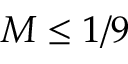<formula> <loc_0><loc_0><loc_500><loc_500>M \leq 1 / 9</formula> 